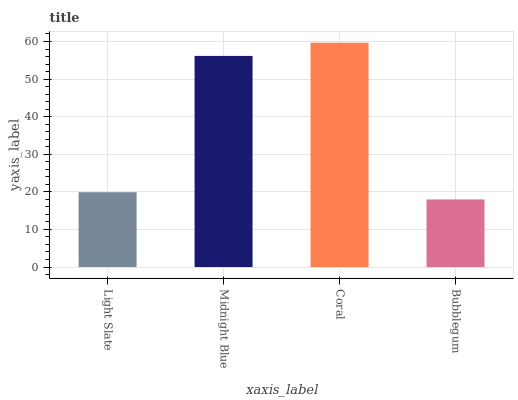Is Bubblegum the minimum?
Answer yes or no. Yes. Is Coral the maximum?
Answer yes or no. Yes. Is Midnight Blue the minimum?
Answer yes or no. No. Is Midnight Blue the maximum?
Answer yes or no. No. Is Midnight Blue greater than Light Slate?
Answer yes or no. Yes. Is Light Slate less than Midnight Blue?
Answer yes or no. Yes. Is Light Slate greater than Midnight Blue?
Answer yes or no. No. Is Midnight Blue less than Light Slate?
Answer yes or no. No. Is Midnight Blue the high median?
Answer yes or no. Yes. Is Light Slate the low median?
Answer yes or no. Yes. Is Bubblegum the high median?
Answer yes or no. No. Is Coral the low median?
Answer yes or no. No. 